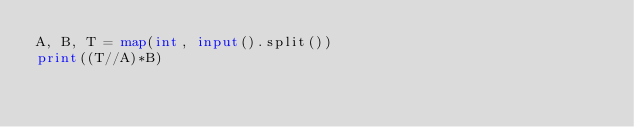<code> <loc_0><loc_0><loc_500><loc_500><_Python_>A, B, T = map(int, input().split())
print((T//A)*B)</code> 